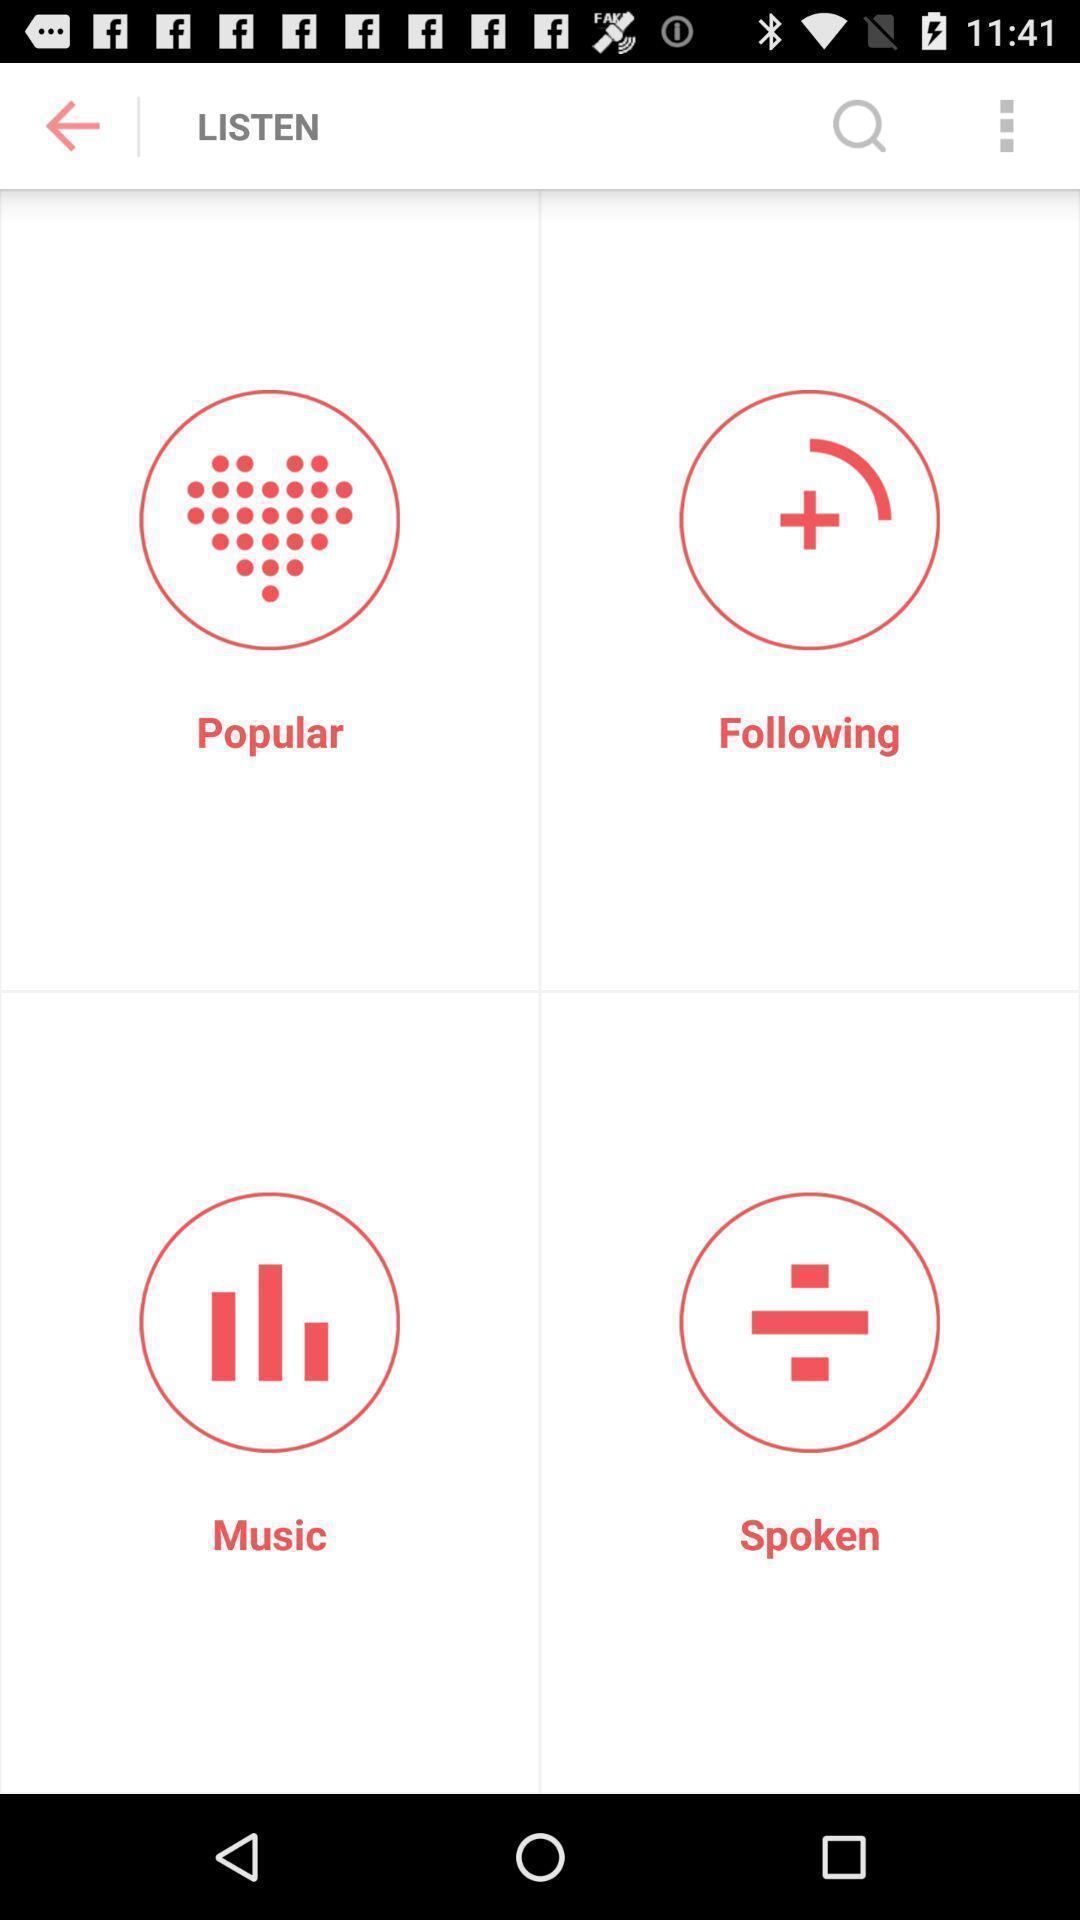Tell me what you see in this picture. Screen displaying multiple options in music application. 